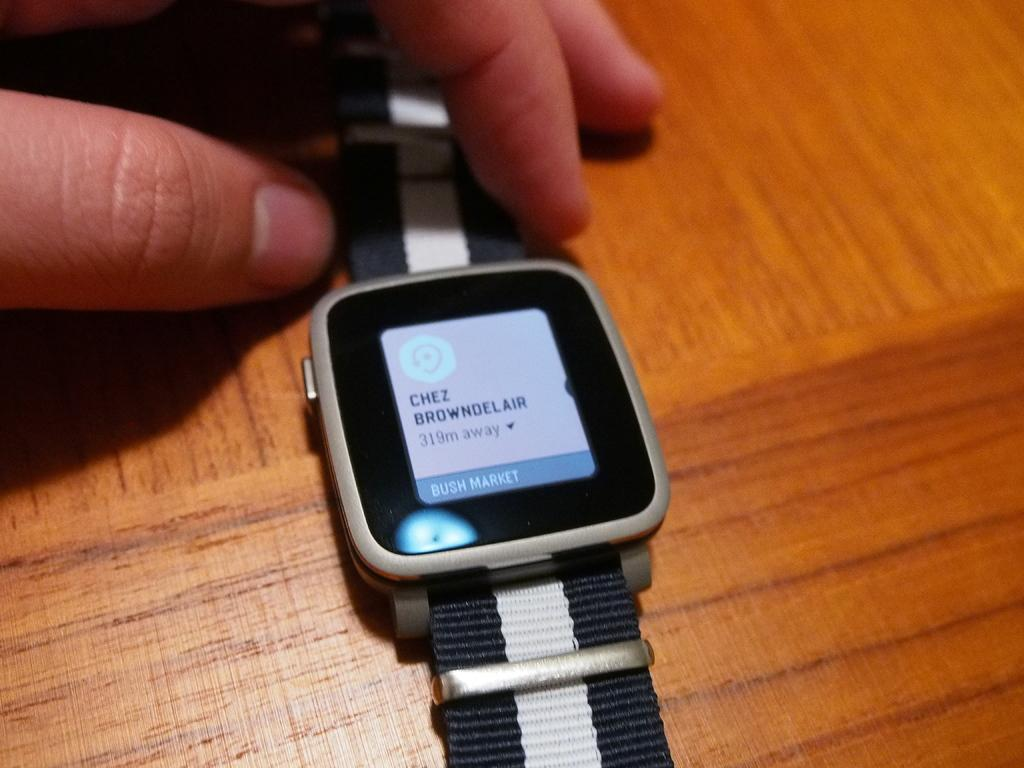<image>
Create a compact narrative representing the image presented. a smart watch says that chex browndel is 319 m away 